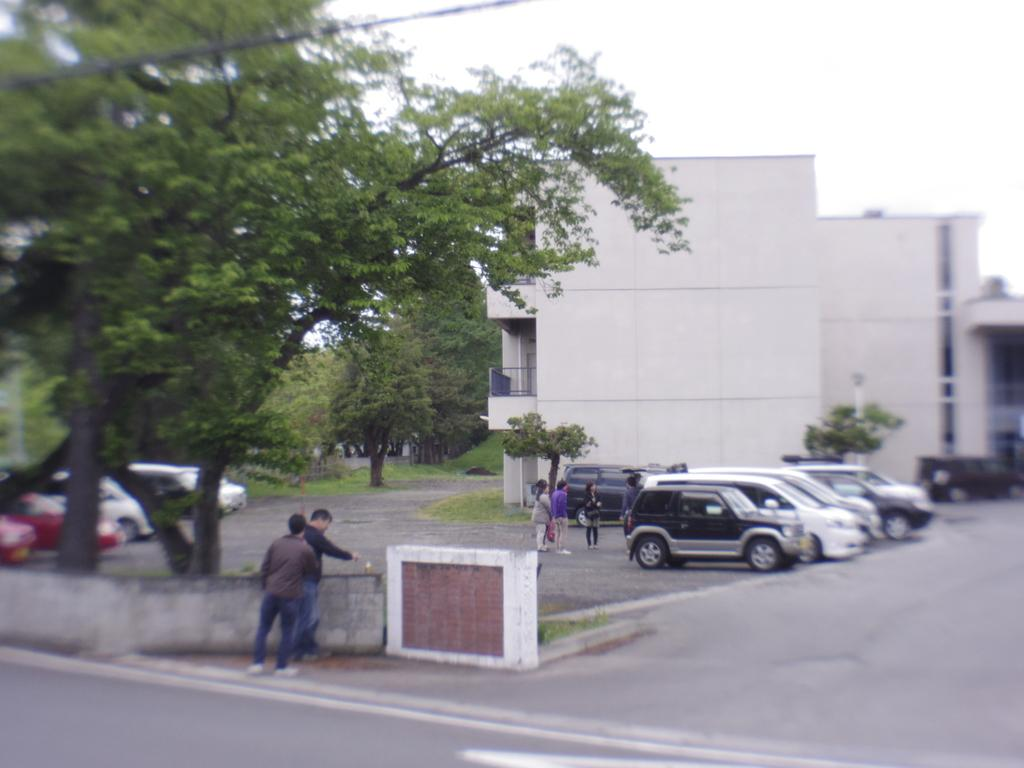What type of vehicles can be seen on the road in the image? There are cars on the road in the image. What else can be seen on the road besides cars? There are people standing on the road in the image. What can be seen in the background of the image? There are trees and buildings in the background of the image. Where is the oven located in the image? There is no oven present in the image. What type of ship can be seen sailing in the background of the image? There is no ship present in the image; it features cars on the road and trees and buildings in the background. 